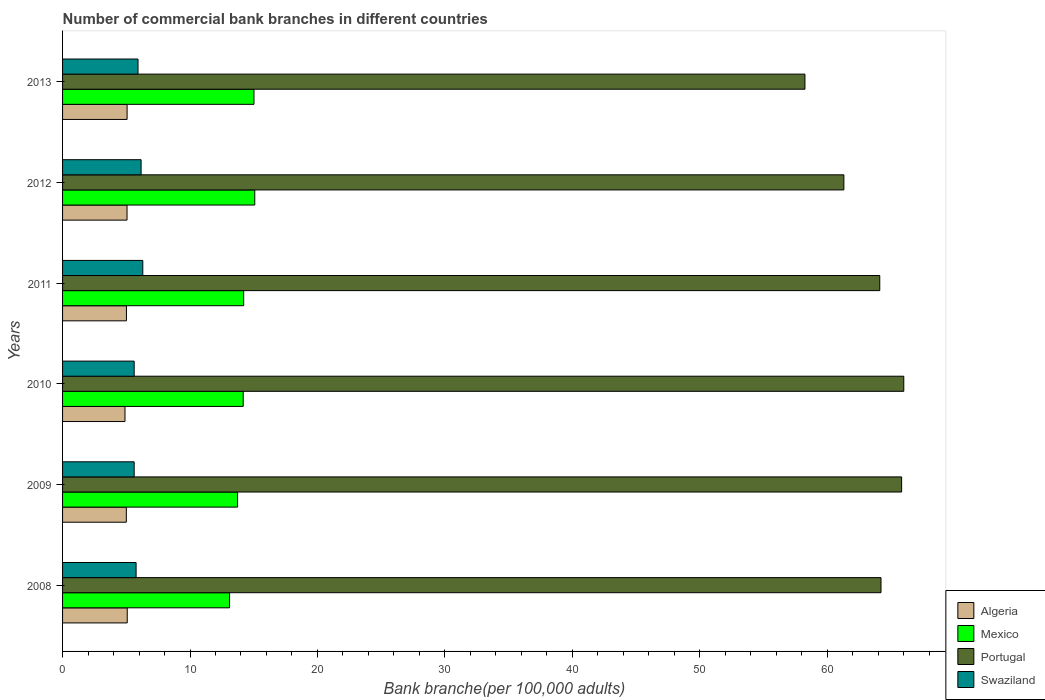How many different coloured bars are there?
Keep it short and to the point. 4. Are the number of bars on each tick of the Y-axis equal?
Provide a succinct answer. Yes. How many bars are there on the 1st tick from the bottom?
Give a very brief answer. 4. What is the label of the 5th group of bars from the top?
Provide a succinct answer. 2009. What is the number of commercial bank branches in Swaziland in 2009?
Your answer should be compact. 5.62. Across all years, what is the maximum number of commercial bank branches in Mexico?
Offer a terse response. 15.08. Across all years, what is the minimum number of commercial bank branches in Algeria?
Ensure brevity in your answer.  4.9. In which year was the number of commercial bank branches in Swaziland maximum?
Offer a terse response. 2011. What is the total number of commercial bank branches in Algeria in the graph?
Your answer should be compact. 30.11. What is the difference between the number of commercial bank branches in Swaziland in 2010 and that in 2013?
Keep it short and to the point. -0.3. What is the difference between the number of commercial bank branches in Mexico in 2011 and the number of commercial bank branches in Algeria in 2012?
Offer a terse response. 9.15. What is the average number of commercial bank branches in Portugal per year?
Ensure brevity in your answer.  63.29. In the year 2011, what is the difference between the number of commercial bank branches in Mexico and number of commercial bank branches in Swaziland?
Your answer should be very brief. 7.92. What is the ratio of the number of commercial bank branches in Portugal in 2008 to that in 2010?
Your answer should be very brief. 0.97. Is the number of commercial bank branches in Swaziland in 2009 less than that in 2011?
Offer a terse response. Yes. Is the difference between the number of commercial bank branches in Mexico in 2009 and 2010 greater than the difference between the number of commercial bank branches in Swaziland in 2009 and 2010?
Offer a very short reply. No. What is the difference between the highest and the second highest number of commercial bank branches in Mexico?
Offer a terse response. 0.06. What is the difference between the highest and the lowest number of commercial bank branches in Portugal?
Your response must be concise. 7.76. Is the sum of the number of commercial bank branches in Portugal in 2008 and 2010 greater than the maximum number of commercial bank branches in Algeria across all years?
Ensure brevity in your answer.  Yes. Is it the case that in every year, the sum of the number of commercial bank branches in Portugal and number of commercial bank branches in Swaziland is greater than the sum of number of commercial bank branches in Algeria and number of commercial bank branches in Mexico?
Offer a very short reply. Yes. Is it the case that in every year, the sum of the number of commercial bank branches in Portugal and number of commercial bank branches in Algeria is greater than the number of commercial bank branches in Mexico?
Make the answer very short. Yes. Are all the bars in the graph horizontal?
Your response must be concise. Yes. How many years are there in the graph?
Your answer should be compact. 6. Does the graph contain any zero values?
Keep it short and to the point. No. Does the graph contain grids?
Offer a very short reply. No. Where does the legend appear in the graph?
Provide a succinct answer. Bottom right. How many legend labels are there?
Give a very brief answer. 4. How are the legend labels stacked?
Your response must be concise. Vertical. What is the title of the graph?
Keep it short and to the point. Number of commercial bank branches in different countries. Does "Mauritania" appear as one of the legend labels in the graph?
Offer a very short reply. No. What is the label or title of the X-axis?
Provide a succinct answer. Bank branche(per 100,0 adults). What is the Bank branche(per 100,000 adults) in Algeria in 2008?
Your response must be concise. 5.07. What is the Bank branche(per 100,000 adults) in Mexico in 2008?
Make the answer very short. 13.11. What is the Bank branche(per 100,000 adults) in Portugal in 2008?
Your answer should be very brief. 64.22. What is the Bank branche(per 100,000 adults) in Swaziland in 2008?
Offer a terse response. 5.77. What is the Bank branche(per 100,000 adults) of Algeria in 2009?
Offer a very short reply. 5. What is the Bank branche(per 100,000 adults) in Mexico in 2009?
Offer a very short reply. 13.73. What is the Bank branche(per 100,000 adults) in Portugal in 2009?
Make the answer very short. 65.84. What is the Bank branche(per 100,000 adults) in Swaziland in 2009?
Provide a succinct answer. 5.62. What is the Bank branche(per 100,000 adults) in Algeria in 2010?
Your answer should be very brief. 4.9. What is the Bank branche(per 100,000 adults) of Mexico in 2010?
Ensure brevity in your answer.  14.17. What is the Bank branche(per 100,000 adults) in Portugal in 2010?
Ensure brevity in your answer.  66.01. What is the Bank branche(per 100,000 adults) of Swaziland in 2010?
Offer a very short reply. 5.62. What is the Bank branche(per 100,000 adults) of Algeria in 2011?
Give a very brief answer. 5.01. What is the Bank branche(per 100,000 adults) in Mexico in 2011?
Make the answer very short. 14.21. What is the Bank branche(per 100,000 adults) in Portugal in 2011?
Your answer should be very brief. 64.13. What is the Bank branche(per 100,000 adults) in Swaziland in 2011?
Your answer should be compact. 6.3. What is the Bank branche(per 100,000 adults) in Algeria in 2012?
Make the answer very short. 5.06. What is the Bank branche(per 100,000 adults) in Mexico in 2012?
Your answer should be very brief. 15.08. What is the Bank branche(per 100,000 adults) of Portugal in 2012?
Keep it short and to the point. 61.31. What is the Bank branche(per 100,000 adults) in Swaziland in 2012?
Give a very brief answer. 6.16. What is the Bank branche(per 100,000 adults) of Algeria in 2013?
Your answer should be very brief. 5.06. What is the Bank branche(per 100,000 adults) in Mexico in 2013?
Keep it short and to the point. 15.02. What is the Bank branche(per 100,000 adults) in Portugal in 2013?
Offer a terse response. 58.25. What is the Bank branche(per 100,000 adults) in Swaziland in 2013?
Your response must be concise. 5.92. Across all years, what is the maximum Bank branche(per 100,000 adults) in Algeria?
Provide a short and direct response. 5.07. Across all years, what is the maximum Bank branche(per 100,000 adults) in Mexico?
Keep it short and to the point. 15.08. Across all years, what is the maximum Bank branche(per 100,000 adults) of Portugal?
Keep it short and to the point. 66.01. Across all years, what is the maximum Bank branche(per 100,000 adults) in Swaziland?
Offer a very short reply. 6.3. Across all years, what is the minimum Bank branche(per 100,000 adults) of Algeria?
Provide a succinct answer. 4.9. Across all years, what is the minimum Bank branche(per 100,000 adults) in Mexico?
Your answer should be compact. 13.11. Across all years, what is the minimum Bank branche(per 100,000 adults) in Portugal?
Your answer should be compact. 58.25. Across all years, what is the minimum Bank branche(per 100,000 adults) in Swaziland?
Provide a succinct answer. 5.62. What is the total Bank branche(per 100,000 adults) in Algeria in the graph?
Provide a short and direct response. 30.11. What is the total Bank branche(per 100,000 adults) in Mexico in the graph?
Ensure brevity in your answer.  85.33. What is the total Bank branche(per 100,000 adults) in Portugal in the graph?
Ensure brevity in your answer.  379.76. What is the total Bank branche(per 100,000 adults) of Swaziland in the graph?
Your response must be concise. 35.39. What is the difference between the Bank branche(per 100,000 adults) of Algeria in 2008 and that in 2009?
Give a very brief answer. 0.07. What is the difference between the Bank branche(per 100,000 adults) of Mexico in 2008 and that in 2009?
Provide a succinct answer. -0.63. What is the difference between the Bank branche(per 100,000 adults) of Portugal in 2008 and that in 2009?
Provide a short and direct response. -1.62. What is the difference between the Bank branche(per 100,000 adults) of Swaziland in 2008 and that in 2009?
Your answer should be compact. 0.15. What is the difference between the Bank branche(per 100,000 adults) of Algeria in 2008 and that in 2010?
Provide a succinct answer. 0.18. What is the difference between the Bank branche(per 100,000 adults) of Mexico in 2008 and that in 2010?
Provide a short and direct response. -1.07. What is the difference between the Bank branche(per 100,000 adults) in Portugal in 2008 and that in 2010?
Provide a short and direct response. -1.79. What is the difference between the Bank branche(per 100,000 adults) in Swaziland in 2008 and that in 2010?
Make the answer very short. 0.15. What is the difference between the Bank branche(per 100,000 adults) in Algeria in 2008 and that in 2011?
Your response must be concise. 0.06. What is the difference between the Bank branche(per 100,000 adults) in Mexico in 2008 and that in 2011?
Offer a terse response. -1.11. What is the difference between the Bank branche(per 100,000 adults) of Portugal in 2008 and that in 2011?
Ensure brevity in your answer.  0.1. What is the difference between the Bank branche(per 100,000 adults) of Swaziland in 2008 and that in 2011?
Make the answer very short. -0.53. What is the difference between the Bank branche(per 100,000 adults) in Algeria in 2008 and that in 2012?
Provide a short and direct response. 0.02. What is the difference between the Bank branche(per 100,000 adults) in Mexico in 2008 and that in 2012?
Your answer should be compact. -1.98. What is the difference between the Bank branche(per 100,000 adults) of Portugal in 2008 and that in 2012?
Provide a succinct answer. 2.91. What is the difference between the Bank branche(per 100,000 adults) of Swaziland in 2008 and that in 2012?
Keep it short and to the point. -0.39. What is the difference between the Bank branche(per 100,000 adults) of Algeria in 2008 and that in 2013?
Make the answer very short. 0.01. What is the difference between the Bank branche(per 100,000 adults) of Mexico in 2008 and that in 2013?
Keep it short and to the point. -1.91. What is the difference between the Bank branche(per 100,000 adults) in Portugal in 2008 and that in 2013?
Your response must be concise. 5.97. What is the difference between the Bank branche(per 100,000 adults) in Swaziland in 2008 and that in 2013?
Offer a terse response. -0.15. What is the difference between the Bank branche(per 100,000 adults) of Algeria in 2009 and that in 2010?
Keep it short and to the point. 0.11. What is the difference between the Bank branche(per 100,000 adults) of Mexico in 2009 and that in 2010?
Give a very brief answer. -0.44. What is the difference between the Bank branche(per 100,000 adults) in Portugal in 2009 and that in 2010?
Your answer should be very brief. -0.17. What is the difference between the Bank branche(per 100,000 adults) of Algeria in 2009 and that in 2011?
Offer a very short reply. -0.01. What is the difference between the Bank branche(per 100,000 adults) of Mexico in 2009 and that in 2011?
Keep it short and to the point. -0.48. What is the difference between the Bank branche(per 100,000 adults) in Portugal in 2009 and that in 2011?
Provide a succinct answer. 1.72. What is the difference between the Bank branche(per 100,000 adults) in Swaziland in 2009 and that in 2011?
Keep it short and to the point. -0.68. What is the difference between the Bank branche(per 100,000 adults) of Algeria in 2009 and that in 2012?
Your answer should be compact. -0.06. What is the difference between the Bank branche(per 100,000 adults) in Mexico in 2009 and that in 2012?
Your response must be concise. -1.35. What is the difference between the Bank branche(per 100,000 adults) of Portugal in 2009 and that in 2012?
Offer a very short reply. 4.53. What is the difference between the Bank branche(per 100,000 adults) of Swaziland in 2009 and that in 2012?
Your answer should be very brief. -0.54. What is the difference between the Bank branche(per 100,000 adults) in Algeria in 2009 and that in 2013?
Ensure brevity in your answer.  -0.06. What is the difference between the Bank branche(per 100,000 adults) in Mexico in 2009 and that in 2013?
Provide a succinct answer. -1.29. What is the difference between the Bank branche(per 100,000 adults) of Portugal in 2009 and that in 2013?
Give a very brief answer. 7.59. What is the difference between the Bank branche(per 100,000 adults) of Swaziland in 2009 and that in 2013?
Your answer should be compact. -0.3. What is the difference between the Bank branche(per 100,000 adults) of Algeria in 2010 and that in 2011?
Ensure brevity in your answer.  -0.12. What is the difference between the Bank branche(per 100,000 adults) of Mexico in 2010 and that in 2011?
Your answer should be compact. -0.04. What is the difference between the Bank branche(per 100,000 adults) in Portugal in 2010 and that in 2011?
Your response must be concise. 1.88. What is the difference between the Bank branche(per 100,000 adults) in Swaziland in 2010 and that in 2011?
Offer a terse response. -0.68. What is the difference between the Bank branche(per 100,000 adults) of Algeria in 2010 and that in 2012?
Make the answer very short. -0.16. What is the difference between the Bank branche(per 100,000 adults) of Mexico in 2010 and that in 2012?
Ensure brevity in your answer.  -0.91. What is the difference between the Bank branche(per 100,000 adults) of Portugal in 2010 and that in 2012?
Offer a terse response. 4.7. What is the difference between the Bank branche(per 100,000 adults) of Swaziland in 2010 and that in 2012?
Your response must be concise. -0.54. What is the difference between the Bank branche(per 100,000 adults) in Algeria in 2010 and that in 2013?
Make the answer very short. -0.17. What is the difference between the Bank branche(per 100,000 adults) of Mexico in 2010 and that in 2013?
Provide a succinct answer. -0.85. What is the difference between the Bank branche(per 100,000 adults) of Portugal in 2010 and that in 2013?
Provide a succinct answer. 7.76. What is the difference between the Bank branche(per 100,000 adults) of Swaziland in 2010 and that in 2013?
Your response must be concise. -0.3. What is the difference between the Bank branche(per 100,000 adults) in Algeria in 2011 and that in 2012?
Provide a succinct answer. -0.05. What is the difference between the Bank branche(per 100,000 adults) in Mexico in 2011 and that in 2012?
Your answer should be very brief. -0.87. What is the difference between the Bank branche(per 100,000 adults) of Portugal in 2011 and that in 2012?
Make the answer very short. 2.82. What is the difference between the Bank branche(per 100,000 adults) in Swaziland in 2011 and that in 2012?
Provide a succinct answer. 0.13. What is the difference between the Bank branche(per 100,000 adults) in Algeria in 2011 and that in 2013?
Provide a short and direct response. -0.05. What is the difference between the Bank branche(per 100,000 adults) of Mexico in 2011 and that in 2013?
Your answer should be compact. -0.81. What is the difference between the Bank branche(per 100,000 adults) in Portugal in 2011 and that in 2013?
Give a very brief answer. 5.87. What is the difference between the Bank branche(per 100,000 adults) in Swaziland in 2011 and that in 2013?
Offer a terse response. 0.38. What is the difference between the Bank branche(per 100,000 adults) in Algeria in 2012 and that in 2013?
Your answer should be compact. -0.01. What is the difference between the Bank branche(per 100,000 adults) in Mexico in 2012 and that in 2013?
Offer a very short reply. 0.06. What is the difference between the Bank branche(per 100,000 adults) in Portugal in 2012 and that in 2013?
Make the answer very short. 3.05. What is the difference between the Bank branche(per 100,000 adults) of Swaziland in 2012 and that in 2013?
Provide a short and direct response. 0.24. What is the difference between the Bank branche(per 100,000 adults) of Algeria in 2008 and the Bank branche(per 100,000 adults) of Mexico in 2009?
Offer a very short reply. -8.66. What is the difference between the Bank branche(per 100,000 adults) of Algeria in 2008 and the Bank branche(per 100,000 adults) of Portugal in 2009?
Ensure brevity in your answer.  -60.77. What is the difference between the Bank branche(per 100,000 adults) of Algeria in 2008 and the Bank branche(per 100,000 adults) of Swaziland in 2009?
Keep it short and to the point. -0.54. What is the difference between the Bank branche(per 100,000 adults) of Mexico in 2008 and the Bank branche(per 100,000 adults) of Portugal in 2009?
Provide a succinct answer. -52.74. What is the difference between the Bank branche(per 100,000 adults) of Mexico in 2008 and the Bank branche(per 100,000 adults) of Swaziland in 2009?
Keep it short and to the point. 7.49. What is the difference between the Bank branche(per 100,000 adults) in Portugal in 2008 and the Bank branche(per 100,000 adults) in Swaziland in 2009?
Your answer should be very brief. 58.6. What is the difference between the Bank branche(per 100,000 adults) of Algeria in 2008 and the Bank branche(per 100,000 adults) of Mexico in 2010?
Offer a terse response. -9.1. What is the difference between the Bank branche(per 100,000 adults) in Algeria in 2008 and the Bank branche(per 100,000 adults) in Portugal in 2010?
Offer a very short reply. -60.94. What is the difference between the Bank branche(per 100,000 adults) in Algeria in 2008 and the Bank branche(per 100,000 adults) in Swaziland in 2010?
Offer a very short reply. -0.54. What is the difference between the Bank branche(per 100,000 adults) of Mexico in 2008 and the Bank branche(per 100,000 adults) of Portugal in 2010?
Provide a short and direct response. -52.9. What is the difference between the Bank branche(per 100,000 adults) in Mexico in 2008 and the Bank branche(per 100,000 adults) in Swaziland in 2010?
Provide a short and direct response. 7.49. What is the difference between the Bank branche(per 100,000 adults) of Portugal in 2008 and the Bank branche(per 100,000 adults) of Swaziland in 2010?
Provide a succinct answer. 58.6. What is the difference between the Bank branche(per 100,000 adults) in Algeria in 2008 and the Bank branche(per 100,000 adults) in Mexico in 2011?
Offer a terse response. -9.14. What is the difference between the Bank branche(per 100,000 adults) in Algeria in 2008 and the Bank branche(per 100,000 adults) in Portugal in 2011?
Offer a very short reply. -59.05. What is the difference between the Bank branche(per 100,000 adults) of Algeria in 2008 and the Bank branche(per 100,000 adults) of Swaziland in 2011?
Offer a very short reply. -1.22. What is the difference between the Bank branche(per 100,000 adults) in Mexico in 2008 and the Bank branche(per 100,000 adults) in Portugal in 2011?
Make the answer very short. -51.02. What is the difference between the Bank branche(per 100,000 adults) in Mexico in 2008 and the Bank branche(per 100,000 adults) in Swaziland in 2011?
Ensure brevity in your answer.  6.81. What is the difference between the Bank branche(per 100,000 adults) of Portugal in 2008 and the Bank branche(per 100,000 adults) of Swaziland in 2011?
Your answer should be very brief. 57.93. What is the difference between the Bank branche(per 100,000 adults) of Algeria in 2008 and the Bank branche(per 100,000 adults) of Mexico in 2012?
Give a very brief answer. -10.01. What is the difference between the Bank branche(per 100,000 adults) of Algeria in 2008 and the Bank branche(per 100,000 adults) of Portugal in 2012?
Keep it short and to the point. -56.23. What is the difference between the Bank branche(per 100,000 adults) in Algeria in 2008 and the Bank branche(per 100,000 adults) in Swaziland in 2012?
Offer a terse response. -1.09. What is the difference between the Bank branche(per 100,000 adults) of Mexico in 2008 and the Bank branche(per 100,000 adults) of Portugal in 2012?
Offer a very short reply. -48.2. What is the difference between the Bank branche(per 100,000 adults) of Mexico in 2008 and the Bank branche(per 100,000 adults) of Swaziland in 2012?
Your answer should be compact. 6.94. What is the difference between the Bank branche(per 100,000 adults) in Portugal in 2008 and the Bank branche(per 100,000 adults) in Swaziland in 2012?
Your answer should be compact. 58.06. What is the difference between the Bank branche(per 100,000 adults) of Algeria in 2008 and the Bank branche(per 100,000 adults) of Mexico in 2013?
Offer a terse response. -9.95. What is the difference between the Bank branche(per 100,000 adults) in Algeria in 2008 and the Bank branche(per 100,000 adults) in Portugal in 2013?
Your answer should be compact. -53.18. What is the difference between the Bank branche(per 100,000 adults) in Algeria in 2008 and the Bank branche(per 100,000 adults) in Swaziland in 2013?
Make the answer very short. -0.85. What is the difference between the Bank branche(per 100,000 adults) of Mexico in 2008 and the Bank branche(per 100,000 adults) of Portugal in 2013?
Offer a terse response. -45.15. What is the difference between the Bank branche(per 100,000 adults) in Mexico in 2008 and the Bank branche(per 100,000 adults) in Swaziland in 2013?
Offer a terse response. 7.19. What is the difference between the Bank branche(per 100,000 adults) in Portugal in 2008 and the Bank branche(per 100,000 adults) in Swaziland in 2013?
Your answer should be compact. 58.3. What is the difference between the Bank branche(per 100,000 adults) of Algeria in 2009 and the Bank branche(per 100,000 adults) of Mexico in 2010?
Your response must be concise. -9.17. What is the difference between the Bank branche(per 100,000 adults) in Algeria in 2009 and the Bank branche(per 100,000 adults) in Portugal in 2010?
Give a very brief answer. -61.01. What is the difference between the Bank branche(per 100,000 adults) of Algeria in 2009 and the Bank branche(per 100,000 adults) of Swaziland in 2010?
Your answer should be very brief. -0.61. What is the difference between the Bank branche(per 100,000 adults) of Mexico in 2009 and the Bank branche(per 100,000 adults) of Portugal in 2010?
Give a very brief answer. -52.28. What is the difference between the Bank branche(per 100,000 adults) of Mexico in 2009 and the Bank branche(per 100,000 adults) of Swaziland in 2010?
Provide a short and direct response. 8.11. What is the difference between the Bank branche(per 100,000 adults) of Portugal in 2009 and the Bank branche(per 100,000 adults) of Swaziland in 2010?
Ensure brevity in your answer.  60.22. What is the difference between the Bank branche(per 100,000 adults) in Algeria in 2009 and the Bank branche(per 100,000 adults) in Mexico in 2011?
Ensure brevity in your answer.  -9.21. What is the difference between the Bank branche(per 100,000 adults) of Algeria in 2009 and the Bank branche(per 100,000 adults) of Portugal in 2011?
Keep it short and to the point. -59.12. What is the difference between the Bank branche(per 100,000 adults) of Algeria in 2009 and the Bank branche(per 100,000 adults) of Swaziland in 2011?
Offer a terse response. -1.29. What is the difference between the Bank branche(per 100,000 adults) of Mexico in 2009 and the Bank branche(per 100,000 adults) of Portugal in 2011?
Keep it short and to the point. -50.39. What is the difference between the Bank branche(per 100,000 adults) in Mexico in 2009 and the Bank branche(per 100,000 adults) in Swaziland in 2011?
Provide a succinct answer. 7.44. What is the difference between the Bank branche(per 100,000 adults) of Portugal in 2009 and the Bank branche(per 100,000 adults) of Swaziland in 2011?
Ensure brevity in your answer.  59.55. What is the difference between the Bank branche(per 100,000 adults) in Algeria in 2009 and the Bank branche(per 100,000 adults) in Mexico in 2012?
Give a very brief answer. -10.08. What is the difference between the Bank branche(per 100,000 adults) in Algeria in 2009 and the Bank branche(per 100,000 adults) in Portugal in 2012?
Your response must be concise. -56.31. What is the difference between the Bank branche(per 100,000 adults) of Algeria in 2009 and the Bank branche(per 100,000 adults) of Swaziland in 2012?
Keep it short and to the point. -1.16. What is the difference between the Bank branche(per 100,000 adults) of Mexico in 2009 and the Bank branche(per 100,000 adults) of Portugal in 2012?
Give a very brief answer. -47.58. What is the difference between the Bank branche(per 100,000 adults) in Mexico in 2009 and the Bank branche(per 100,000 adults) in Swaziland in 2012?
Ensure brevity in your answer.  7.57. What is the difference between the Bank branche(per 100,000 adults) in Portugal in 2009 and the Bank branche(per 100,000 adults) in Swaziland in 2012?
Make the answer very short. 59.68. What is the difference between the Bank branche(per 100,000 adults) of Algeria in 2009 and the Bank branche(per 100,000 adults) of Mexico in 2013?
Your response must be concise. -10.02. What is the difference between the Bank branche(per 100,000 adults) in Algeria in 2009 and the Bank branche(per 100,000 adults) in Portugal in 2013?
Give a very brief answer. -53.25. What is the difference between the Bank branche(per 100,000 adults) of Algeria in 2009 and the Bank branche(per 100,000 adults) of Swaziland in 2013?
Provide a short and direct response. -0.92. What is the difference between the Bank branche(per 100,000 adults) in Mexico in 2009 and the Bank branche(per 100,000 adults) in Portugal in 2013?
Offer a very short reply. -44.52. What is the difference between the Bank branche(per 100,000 adults) in Mexico in 2009 and the Bank branche(per 100,000 adults) in Swaziland in 2013?
Offer a very short reply. 7.81. What is the difference between the Bank branche(per 100,000 adults) of Portugal in 2009 and the Bank branche(per 100,000 adults) of Swaziland in 2013?
Ensure brevity in your answer.  59.92. What is the difference between the Bank branche(per 100,000 adults) of Algeria in 2010 and the Bank branche(per 100,000 adults) of Mexico in 2011?
Your answer should be compact. -9.31. What is the difference between the Bank branche(per 100,000 adults) of Algeria in 2010 and the Bank branche(per 100,000 adults) of Portugal in 2011?
Make the answer very short. -59.23. What is the difference between the Bank branche(per 100,000 adults) of Algeria in 2010 and the Bank branche(per 100,000 adults) of Swaziland in 2011?
Keep it short and to the point. -1.4. What is the difference between the Bank branche(per 100,000 adults) in Mexico in 2010 and the Bank branche(per 100,000 adults) in Portugal in 2011?
Provide a short and direct response. -49.95. What is the difference between the Bank branche(per 100,000 adults) of Mexico in 2010 and the Bank branche(per 100,000 adults) of Swaziland in 2011?
Offer a very short reply. 7.88. What is the difference between the Bank branche(per 100,000 adults) in Portugal in 2010 and the Bank branche(per 100,000 adults) in Swaziland in 2011?
Give a very brief answer. 59.71. What is the difference between the Bank branche(per 100,000 adults) of Algeria in 2010 and the Bank branche(per 100,000 adults) of Mexico in 2012?
Offer a very short reply. -10.18. What is the difference between the Bank branche(per 100,000 adults) of Algeria in 2010 and the Bank branche(per 100,000 adults) of Portugal in 2012?
Give a very brief answer. -56.41. What is the difference between the Bank branche(per 100,000 adults) of Algeria in 2010 and the Bank branche(per 100,000 adults) of Swaziland in 2012?
Make the answer very short. -1.26. What is the difference between the Bank branche(per 100,000 adults) in Mexico in 2010 and the Bank branche(per 100,000 adults) in Portugal in 2012?
Provide a short and direct response. -47.14. What is the difference between the Bank branche(per 100,000 adults) of Mexico in 2010 and the Bank branche(per 100,000 adults) of Swaziland in 2012?
Keep it short and to the point. 8.01. What is the difference between the Bank branche(per 100,000 adults) of Portugal in 2010 and the Bank branche(per 100,000 adults) of Swaziland in 2012?
Ensure brevity in your answer.  59.85. What is the difference between the Bank branche(per 100,000 adults) of Algeria in 2010 and the Bank branche(per 100,000 adults) of Mexico in 2013?
Provide a succinct answer. -10.12. What is the difference between the Bank branche(per 100,000 adults) of Algeria in 2010 and the Bank branche(per 100,000 adults) of Portugal in 2013?
Provide a succinct answer. -53.36. What is the difference between the Bank branche(per 100,000 adults) of Algeria in 2010 and the Bank branche(per 100,000 adults) of Swaziland in 2013?
Ensure brevity in your answer.  -1.02. What is the difference between the Bank branche(per 100,000 adults) of Mexico in 2010 and the Bank branche(per 100,000 adults) of Portugal in 2013?
Provide a succinct answer. -44.08. What is the difference between the Bank branche(per 100,000 adults) of Mexico in 2010 and the Bank branche(per 100,000 adults) of Swaziland in 2013?
Give a very brief answer. 8.25. What is the difference between the Bank branche(per 100,000 adults) of Portugal in 2010 and the Bank branche(per 100,000 adults) of Swaziland in 2013?
Offer a terse response. 60.09. What is the difference between the Bank branche(per 100,000 adults) in Algeria in 2011 and the Bank branche(per 100,000 adults) in Mexico in 2012?
Your answer should be compact. -10.07. What is the difference between the Bank branche(per 100,000 adults) in Algeria in 2011 and the Bank branche(per 100,000 adults) in Portugal in 2012?
Provide a succinct answer. -56.3. What is the difference between the Bank branche(per 100,000 adults) of Algeria in 2011 and the Bank branche(per 100,000 adults) of Swaziland in 2012?
Offer a terse response. -1.15. What is the difference between the Bank branche(per 100,000 adults) in Mexico in 2011 and the Bank branche(per 100,000 adults) in Portugal in 2012?
Keep it short and to the point. -47.1. What is the difference between the Bank branche(per 100,000 adults) of Mexico in 2011 and the Bank branche(per 100,000 adults) of Swaziland in 2012?
Provide a succinct answer. 8.05. What is the difference between the Bank branche(per 100,000 adults) of Portugal in 2011 and the Bank branche(per 100,000 adults) of Swaziland in 2012?
Keep it short and to the point. 57.96. What is the difference between the Bank branche(per 100,000 adults) in Algeria in 2011 and the Bank branche(per 100,000 adults) in Mexico in 2013?
Provide a succinct answer. -10.01. What is the difference between the Bank branche(per 100,000 adults) of Algeria in 2011 and the Bank branche(per 100,000 adults) of Portugal in 2013?
Your answer should be very brief. -53.24. What is the difference between the Bank branche(per 100,000 adults) of Algeria in 2011 and the Bank branche(per 100,000 adults) of Swaziland in 2013?
Make the answer very short. -0.91. What is the difference between the Bank branche(per 100,000 adults) in Mexico in 2011 and the Bank branche(per 100,000 adults) in Portugal in 2013?
Provide a succinct answer. -44.04. What is the difference between the Bank branche(per 100,000 adults) of Mexico in 2011 and the Bank branche(per 100,000 adults) of Swaziland in 2013?
Your answer should be very brief. 8.29. What is the difference between the Bank branche(per 100,000 adults) of Portugal in 2011 and the Bank branche(per 100,000 adults) of Swaziland in 2013?
Provide a short and direct response. 58.2. What is the difference between the Bank branche(per 100,000 adults) in Algeria in 2012 and the Bank branche(per 100,000 adults) in Mexico in 2013?
Your response must be concise. -9.96. What is the difference between the Bank branche(per 100,000 adults) of Algeria in 2012 and the Bank branche(per 100,000 adults) of Portugal in 2013?
Your answer should be compact. -53.2. What is the difference between the Bank branche(per 100,000 adults) in Algeria in 2012 and the Bank branche(per 100,000 adults) in Swaziland in 2013?
Offer a very short reply. -0.86. What is the difference between the Bank branche(per 100,000 adults) of Mexico in 2012 and the Bank branche(per 100,000 adults) of Portugal in 2013?
Ensure brevity in your answer.  -43.17. What is the difference between the Bank branche(per 100,000 adults) in Mexico in 2012 and the Bank branche(per 100,000 adults) in Swaziland in 2013?
Offer a very short reply. 9.16. What is the difference between the Bank branche(per 100,000 adults) of Portugal in 2012 and the Bank branche(per 100,000 adults) of Swaziland in 2013?
Provide a short and direct response. 55.39. What is the average Bank branche(per 100,000 adults) of Algeria per year?
Offer a terse response. 5.02. What is the average Bank branche(per 100,000 adults) of Mexico per year?
Keep it short and to the point. 14.22. What is the average Bank branche(per 100,000 adults) in Portugal per year?
Offer a terse response. 63.29. What is the average Bank branche(per 100,000 adults) of Swaziland per year?
Provide a succinct answer. 5.9. In the year 2008, what is the difference between the Bank branche(per 100,000 adults) of Algeria and Bank branche(per 100,000 adults) of Mexico?
Make the answer very short. -8.03. In the year 2008, what is the difference between the Bank branche(per 100,000 adults) of Algeria and Bank branche(per 100,000 adults) of Portugal?
Make the answer very short. -59.15. In the year 2008, what is the difference between the Bank branche(per 100,000 adults) in Algeria and Bank branche(per 100,000 adults) in Swaziland?
Make the answer very short. -0.7. In the year 2008, what is the difference between the Bank branche(per 100,000 adults) in Mexico and Bank branche(per 100,000 adults) in Portugal?
Your answer should be compact. -51.12. In the year 2008, what is the difference between the Bank branche(per 100,000 adults) of Mexico and Bank branche(per 100,000 adults) of Swaziland?
Your answer should be compact. 7.34. In the year 2008, what is the difference between the Bank branche(per 100,000 adults) in Portugal and Bank branche(per 100,000 adults) in Swaziland?
Make the answer very short. 58.45. In the year 2009, what is the difference between the Bank branche(per 100,000 adults) of Algeria and Bank branche(per 100,000 adults) of Mexico?
Your answer should be very brief. -8.73. In the year 2009, what is the difference between the Bank branche(per 100,000 adults) of Algeria and Bank branche(per 100,000 adults) of Portugal?
Your answer should be compact. -60.84. In the year 2009, what is the difference between the Bank branche(per 100,000 adults) of Algeria and Bank branche(per 100,000 adults) of Swaziland?
Make the answer very short. -0.62. In the year 2009, what is the difference between the Bank branche(per 100,000 adults) in Mexico and Bank branche(per 100,000 adults) in Portugal?
Keep it short and to the point. -52.11. In the year 2009, what is the difference between the Bank branche(per 100,000 adults) of Mexico and Bank branche(per 100,000 adults) of Swaziland?
Provide a short and direct response. 8.11. In the year 2009, what is the difference between the Bank branche(per 100,000 adults) in Portugal and Bank branche(per 100,000 adults) in Swaziland?
Keep it short and to the point. 60.22. In the year 2010, what is the difference between the Bank branche(per 100,000 adults) of Algeria and Bank branche(per 100,000 adults) of Mexico?
Offer a very short reply. -9.28. In the year 2010, what is the difference between the Bank branche(per 100,000 adults) of Algeria and Bank branche(per 100,000 adults) of Portugal?
Keep it short and to the point. -61.11. In the year 2010, what is the difference between the Bank branche(per 100,000 adults) in Algeria and Bank branche(per 100,000 adults) in Swaziland?
Make the answer very short. -0.72. In the year 2010, what is the difference between the Bank branche(per 100,000 adults) in Mexico and Bank branche(per 100,000 adults) in Portugal?
Keep it short and to the point. -51.84. In the year 2010, what is the difference between the Bank branche(per 100,000 adults) in Mexico and Bank branche(per 100,000 adults) in Swaziland?
Provide a short and direct response. 8.56. In the year 2010, what is the difference between the Bank branche(per 100,000 adults) of Portugal and Bank branche(per 100,000 adults) of Swaziland?
Your answer should be compact. 60.39. In the year 2011, what is the difference between the Bank branche(per 100,000 adults) of Algeria and Bank branche(per 100,000 adults) of Mexico?
Offer a very short reply. -9.2. In the year 2011, what is the difference between the Bank branche(per 100,000 adults) of Algeria and Bank branche(per 100,000 adults) of Portugal?
Your answer should be very brief. -59.11. In the year 2011, what is the difference between the Bank branche(per 100,000 adults) of Algeria and Bank branche(per 100,000 adults) of Swaziland?
Keep it short and to the point. -1.28. In the year 2011, what is the difference between the Bank branche(per 100,000 adults) of Mexico and Bank branche(per 100,000 adults) of Portugal?
Make the answer very short. -49.91. In the year 2011, what is the difference between the Bank branche(per 100,000 adults) of Mexico and Bank branche(per 100,000 adults) of Swaziland?
Ensure brevity in your answer.  7.92. In the year 2011, what is the difference between the Bank branche(per 100,000 adults) in Portugal and Bank branche(per 100,000 adults) in Swaziland?
Make the answer very short. 57.83. In the year 2012, what is the difference between the Bank branche(per 100,000 adults) of Algeria and Bank branche(per 100,000 adults) of Mexico?
Provide a short and direct response. -10.02. In the year 2012, what is the difference between the Bank branche(per 100,000 adults) in Algeria and Bank branche(per 100,000 adults) in Portugal?
Provide a short and direct response. -56.25. In the year 2012, what is the difference between the Bank branche(per 100,000 adults) in Algeria and Bank branche(per 100,000 adults) in Swaziland?
Ensure brevity in your answer.  -1.1. In the year 2012, what is the difference between the Bank branche(per 100,000 adults) of Mexico and Bank branche(per 100,000 adults) of Portugal?
Give a very brief answer. -46.23. In the year 2012, what is the difference between the Bank branche(per 100,000 adults) of Mexico and Bank branche(per 100,000 adults) of Swaziland?
Your answer should be very brief. 8.92. In the year 2012, what is the difference between the Bank branche(per 100,000 adults) of Portugal and Bank branche(per 100,000 adults) of Swaziland?
Offer a terse response. 55.15. In the year 2013, what is the difference between the Bank branche(per 100,000 adults) in Algeria and Bank branche(per 100,000 adults) in Mexico?
Provide a succinct answer. -9.96. In the year 2013, what is the difference between the Bank branche(per 100,000 adults) of Algeria and Bank branche(per 100,000 adults) of Portugal?
Offer a terse response. -53.19. In the year 2013, what is the difference between the Bank branche(per 100,000 adults) in Algeria and Bank branche(per 100,000 adults) in Swaziland?
Offer a terse response. -0.86. In the year 2013, what is the difference between the Bank branche(per 100,000 adults) of Mexico and Bank branche(per 100,000 adults) of Portugal?
Provide a succinct answer. -43.23. In the year 2013, what is the difference between the Bank branche(per 100,000 adults) in Mexico and Bank branche(per 100,000 adults) in Swaziland?
Offer a very short reply. 9.1. In the year 2013, what is the difference between the Bank branche(per 100,000 adults) of Portugal and Bank branche(per 100,000 adults) of Swaziland?
Your answer should be very brief. 52.33. What is the ratio of the Bank branche(per 100,000 adults) of Algeria in 2008 to that in 2009?
Your response must be concise. 1.01. What is the ratio of the Bank branche(per 100,000 adults) of Mexico in 2008 to that in 2009?
Your response must be concise. 0.95. What is the ratio of the Bank branche(per 100,000 adults) of Portugal in 2008 to that in 2009?
Make the answer very short. 0.98. What is the ratio of the Bank branche(per 100,000 adults) of Swaziland in 2008 to that in 2009?
Your response must be concise. 1.03. What is the ratio of the Bank branche(per 100,000 adults) in Algeria in 2008 to that in 2010?
Make the answer very short. 1.04. What is the ratio of the Bank branche(per 100,000 adults) of Mexico in 2008 to that in 2010?
Make the answer very short. 0.92. What is the ratio of the Bank branche(per 100,000 adults) in Portugal in 2008 to that in 2010?
Your response must be concise. 0.97. What is the ratio of the Bank branche(per 100,000 adults) of Swaziland in 2008 to that in 2010?
Provide a succinct answer. 1.03. What is the ratio of the Bank branche(per 100,000 adults) in Algeria in 2008 to that in 2011?
Your response must be concise. 1.01. What is the ratio of the Bank branche(per 100,000 adults) of Mexico in 2008 to that in 2011?
Give a very brief answer. 0.92. What is the ratio of the Bank branche(per 100,000 adults) of Swaziland in 2008 to that in 2011?
Keep it short and to the point. 0.92. What is the ratio of the Bank branche(per 100,000 adults) in Algeria in 2008 to that in 2012?
Give a very brief answer. 1. What is the ratio of the Bank branche(per 100,000 adults) of Mexico in 2008 to that in 2012?
Provide a succinct answer. 0.87. What is the ratio of the Bank branche(per 100,000 adults) of Portugal in 2008 to that in 2012?
Give a very brief answer. 1.05. What is the ratio of the Bank branche(per 100,000 adults) in Swaziland in 2008 to that in 2012?
Offer a very short reply. 0.94. What is the ratio of the Bank branche(per 100,000 adults) of Algeria in 2008 to that in 2013?
Keep it short and to the point. 1. What is the ratio of the Bank branche(per 100,000 adults) in Mexico in 2008 to that in 2013?
Offer a very short reply. 0.87. What is the ratio of the Bank branche(per 100,000 adults) in Portugal in 2008 to that in 2013?
Your answer should be compact. 1.1. What is the ratio of the Bank branche(per 100,000 adults) in Swaziland in 2008 to that in 2013?
Provide a short and direct response. 0.97. What is the ratio of the Bank branche(per 100,000 adults) in Algeria in 2009 to that in 2010?
Your answer should be very brief. 1.02. What is the ratio of the Bank branche(per 100,000 adults) of Mexico in 2009 to that in 2010?
Offer a terse response. 0.97. What is the ratio of the Bank branche(per 100,000 adults) of Swaziland in 2009 to that in 2010?
Make the answer very short. 1. What is the ratio of the Bank branche(per 100,000 adults) in Algeria in 2009 to that in 2011?
Provide a succinct answer. 1. What is the ratio of the Bank branche(per 100,000 adults) in Mexico in 2009 to that in 2011?
Your answer should be compact. 0.97. What is the ratio of the Bank branche(per 100,000 adults) of Portugal in 2009 to that in 2011?
Ensure brevity in your answer.  1.03. What is the ratio of the Bank branche(per 100,000 adults) of Swaziland in 2009 to that in 2011?
Give a very brief answer. 0.89. What is the ratio of the Bank branche(per 100,000 adults) of Algeria in 2009 to that in 2012?
Keep it short and to the point. 0.99. What is the ratio of the Bank branche(per 100,000 adults) of Mexico in 2009 to that in 2012?
Offer a very short reply. 0.91. What is the ratio of the Bank branche(per 100,000 adults) in Portugal in 2009 to that in 2012?
Your answer should be compact. 1.07. What is the ratio of the Bank branche(per 100,000 adults) in Swaziland in 2009 to that in 2012?
Your answer should be compact. 0.91. What is the ratio of the Bank branche(per 100,000 adults) in Mexico in 2009 to that in 2013?
Your answer should be very brief. 0.91. What is the ratio of the Bank branche(per 100,000 adults) of Portugal in 2009 to that in 2013?
Your response must be concise. 1.13. What is the ratio of the Bank branche(per 100,000 adults) in Swaziland in 2009 to that in 2013?
Offer a terse response. 0.95. What is the ratio of the Bank branche(per 100,000 adults) of Algeria in 2010 to that in 2011?
Your answer should be compact. 0.98. What is the ratio of the Bank branche(per 100,000 adults) in Mexico in 2010 to that in 2011?
Provide a short and direct response. 1. What is the ratio of the Bank branche(per 100,000 adults) in Portugal in 2010 to that in 2011?
Your answer should be very brief. 1.03. What is the ratio of the Bank branche(per 100,000 adults) of Swaziland in 2010 to that in 2011?
Your answer should be compact. 0.89. What is the ratio of the Bank branche(per 100,000 adults) of Algeria in 2010 to that in 2012?
Your answer should be compact. 0.97. What is the ratio of the Bank branche(per 100,000 adults) of Mexico in 2010 to that in 2012?
Give a very brief answer. 0.94. What is the ratio of the Bank branche(per 100,000 adults) in Portugal in 2010 to that in 2012?
Keep it short and to the point. 1.08. What is the ratio of the Bank branche(per 100,000 adults) of Swaziland in 2010 to that in 2012?
Your answer should be very brief. 0.91. What is the ratio of the Bank branche(per 100,000 adults) in Algeria in 2010 to that in 2013?
Offer a very short reply. 0.97. What is the ratio of the Bank branche(per 100,000 adults) in Mexico in 2010 to that in 2013?
Provide a succinct answer. 0.94. What is the ratio of the Bank branche(per 100,000 adults) of Portugal in 2010 to that in 2013?
Keep it short and to the point. 1.13. What is the ratio of the Bank branche(per 100,000 adults) of Swaziland in 2010 to that in 2013?
Provide a short and direct response. 0.95. What is the ratio of the Bank branche(per 100,000 adults) of Mexico in 2011 to that in 2012?
Offer a terse response. 0.94. What is the ratio of the Bank branche(per 100,000 adults) of Portugal in 2011 to that in 2012?
Offer a terse response. 1.05. What is the ratio of the Bank branche(per 100,000 adults) of Swaziland in 2011 to that in 2012?
Provide a short and direct response. 1.02. What is the ratio of the Bank branche(per 100,000 adults) of Algeria in 2011 to that in 2013?
Offer a very short reply. 0.99. What is the ratio of the Bank branche(per 100,000 adults) of Mexico in 2011 to that in 2013?
Your answer should be compact. 0.95. What is the ratio of the Bank branche(per 100,000 adults) of Portugal in 2011 to that in 2013?
Make the answer very short. 1.1. What is the ratio of the Bank branche(per 100,000 adults) of Swaziland in 2011 to that in 2013?
Your answer should be compact. 1.06. What is the ratio of the Bank branche(per 100,000 adults) in Algeria in 2012 to that in 2013?
Provide a succinct answer. 1. What is the ratio of the Bank branche(per 100,000 adults) of Portugal in 2012 to that in 2013?
Provide a short and direct response. 1.05. What is the ratio of the Bank branche(per 100,000 adults) in Swaziland in 2012 to that in 2013?
Make the answer very short. 1.04. What is the difference between the highest and the second highest Bank branche(per 100,000 adults) of Algeria?
Keep it short and to the point. 0.01. What is the difference between the highest and the second highest Bank branche(per 100,000 adults) in Mexico?
Keep it short and to the point. 0.06. What is the difference between the highest and the second highest Bank branche(per 100,000 adults) of Portugal?
Make the answer very short. 0.17. What is the difference between the highest and the second highest Bank branche(per 100,000 adults) in Swaziland?
Your answer should be compact. 0.13. What is the difference between the highest and the lowest Bank branche(per 100,000 adults) in Algeria?
Make the answer very short. 0.18. What is the difference between the highest and the lowest Bank branche(per 100,000 adults) of Mexico?
Make the answer very short. 1.98. What is the difference between the highest and the lowest Bank branche(per 100,000 adults) in Portugal?
Your response must be concise. 7.76. What is the difference between the highest and the lowest Bank branche(per 100,000 adults) in Swaziland?
Keep it short and to the point. 0.68. 